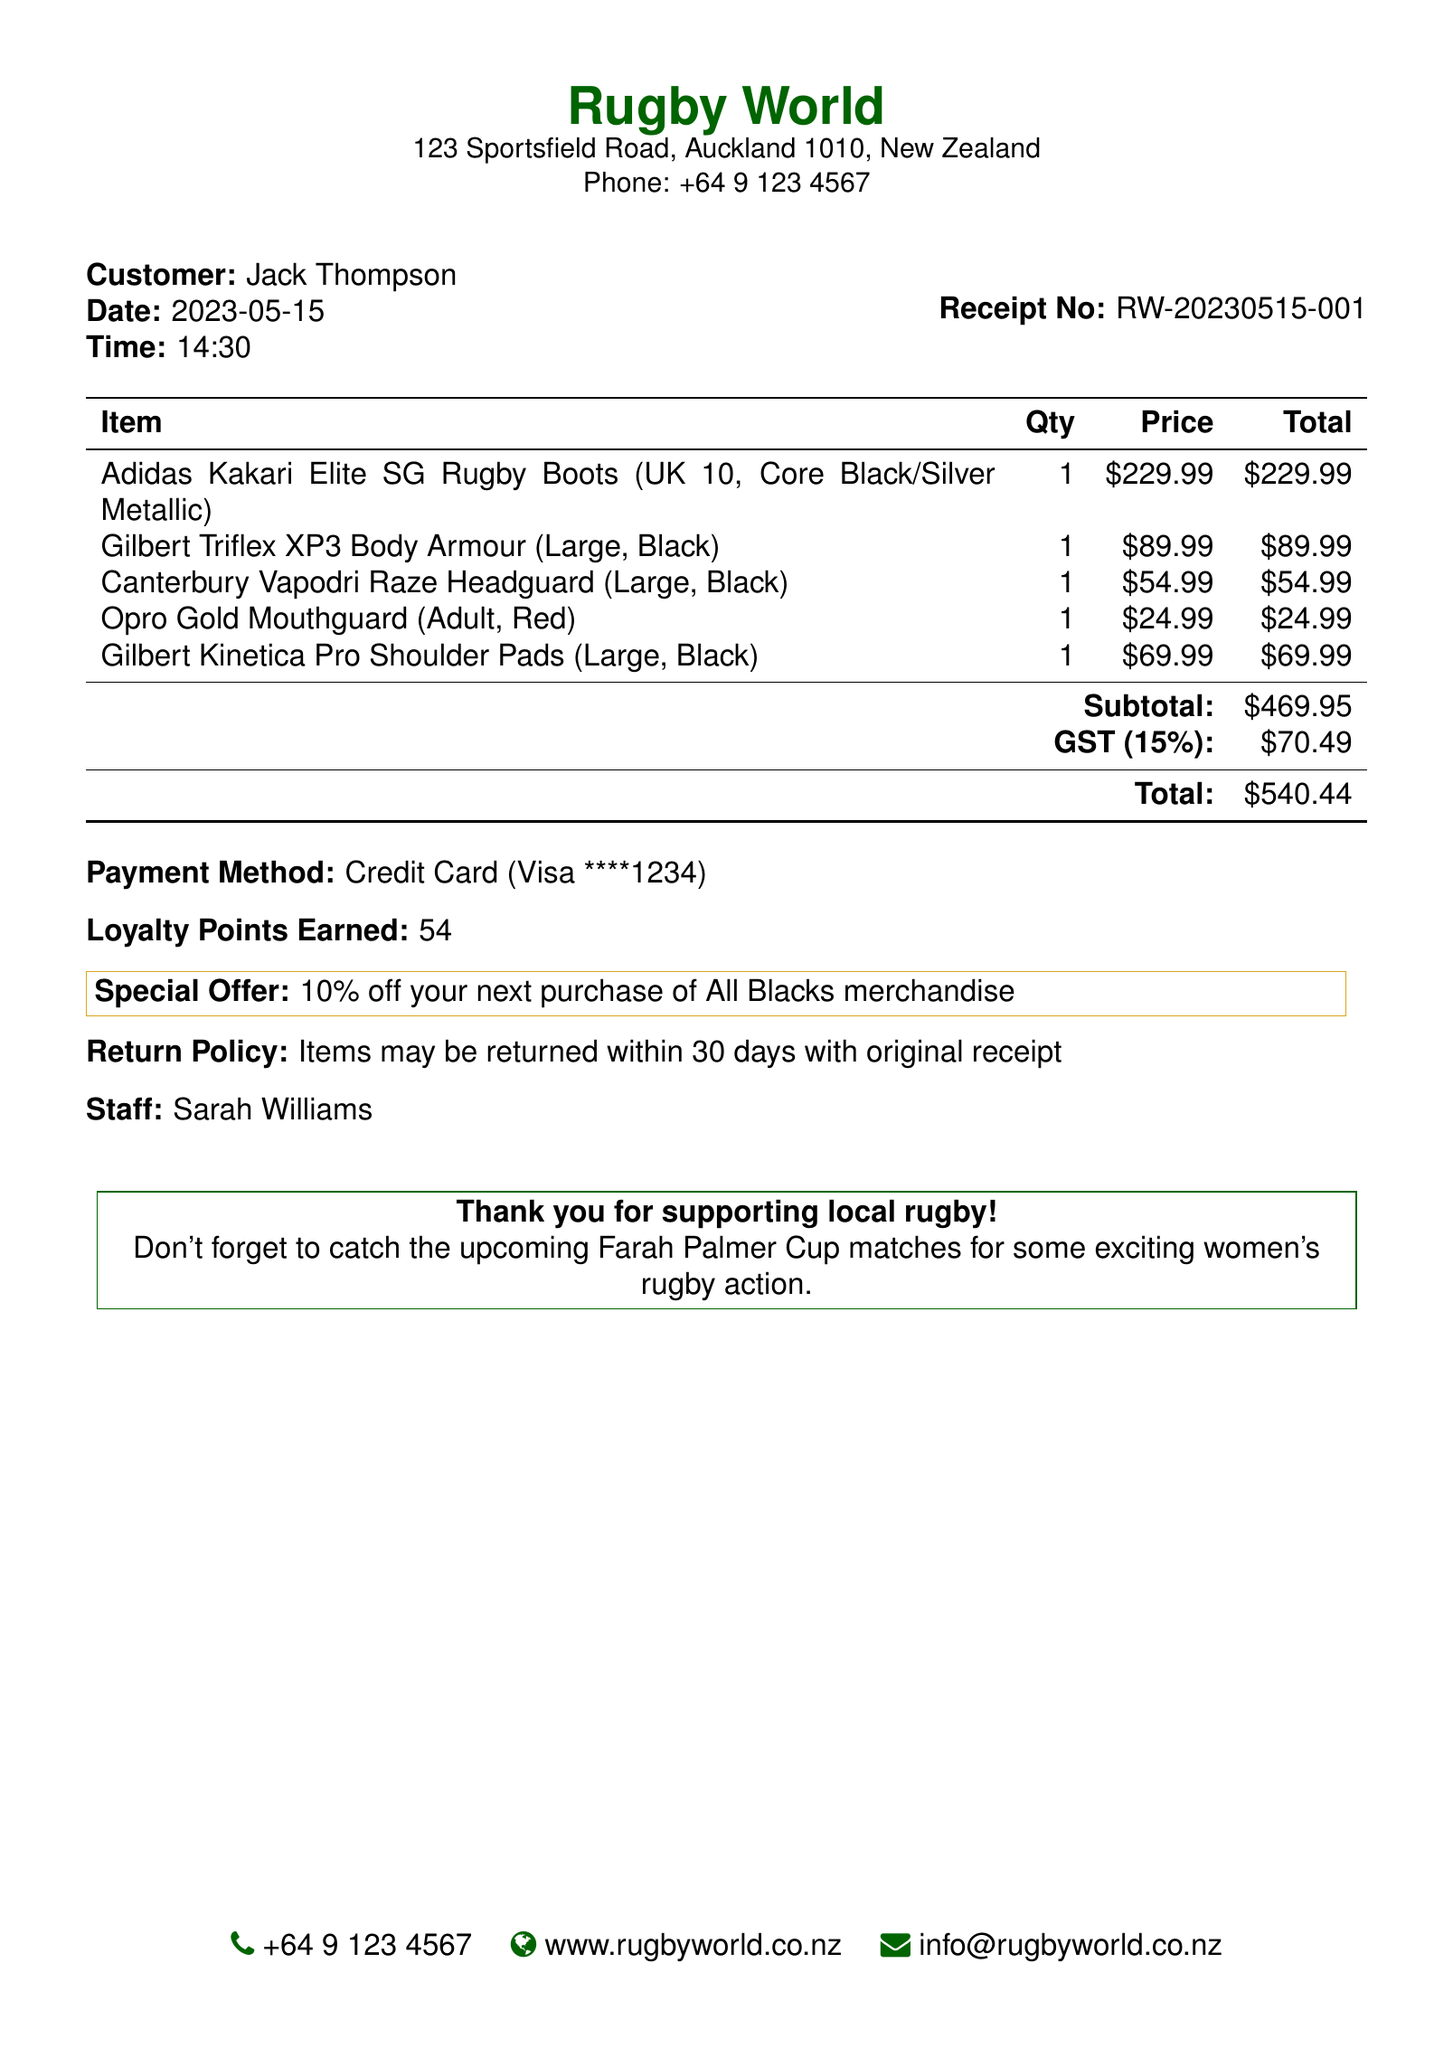What is the name of the store? The store's name is provided at the top of the document.
Answer: Rugby World Who is the customer? The document lists the customer’s name prominently.
Answer: Jack Thompson What is the total amount spent? The total is calculated from the subtotal and GST, clearly stated in the document.
Answer: 540.44 When was the purchase made? The date of the transaction is noted in the document under the customer information.
Answer: 2023-05-15 How many loyalty points were earned? The document highlights the loyalty points earned at the bottom.
Answer: 54 What is the return policy? The return policy regarding the items can be found near the payment details.
Answer: Items may be returned within 30 days with original receipt What payment method was used? The payment method used is explicitly stated in the document.
Answer: Credit Card What special offer is mentioned? The special offer is indicated towards the end of the receipt.
Answer: 10% off your next purchase of All Blacks merchandise What is the name of the staff member? The staff name is mentioned towards the bottom of the document.
Answer: Sarah Williams 